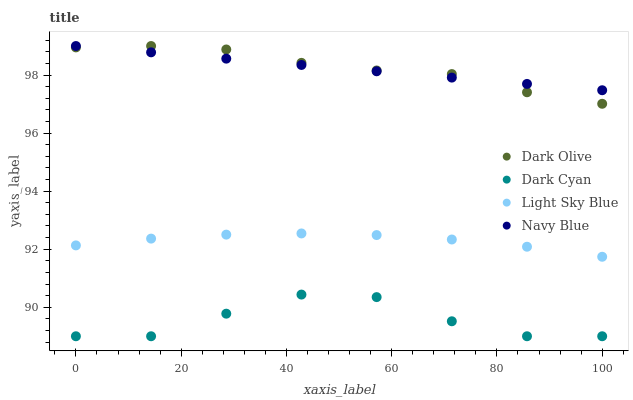Does Dark Cyan have the minimum area under the curve?
Answer yes or no. Yes. Does Dark Olive have the maximum area under the curve?
Answer yes or no. Yes. Does Navy Blue have the minimum area under the curve?
Answer yes or no. No. Does Navy Blue have the maximum area under the curve?
Answer yes or no. No. Is Navy Blue the smoothest?
Answer yes or no. Yes. Is Dark Cyan the roughest?
Answer yes or no. Yes. Is Dark Olive the smoothest?
Answer yes or no. No. Is Dark Olive the roughest?
Answer yes or no. No. Does Dark Cyan have the lowest value?
Answer yes or no. Yes. Does Dark Olive have the lowest value?
Answer yes or no. No. Does Dark Olive have the highest value?
Answer yes or no. Yes. Does Light Sky Blue have the highest value?
Answer yes or no. No. Is Dark Cyan less than Navy Blue?
Answer yes or no. Yes. Is Navy Blue greater than Dark Cyan?
Answer yes or no. Yes. Does Dark Olive intersect Navy Blue?
Answer yes or no. Yes. Is Dark Olive less than Navy Blue?
Answer yes or no. No. Is Dark Olive greater than Navy Blue?
Answer yes or no. No. Does Dark Cyan intersect Navy Blue?
Answer yes or no. No. 